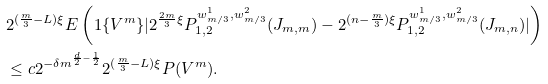Convert formula to latex. <formula><loc_0><loc_0><loc_500><loc_500>& 2 ^ { ( \frac { m } { 3 } - L ) \xi } E \left ( { 1 } \{ V ^ { m } \} | 2 ^ { \frac { 2 m } { 3 } \xi } P ^ { w ^ { 1 } _ { m / 3 } , w ^ { 2 } _ { m / 3 } } _ { 1 , 2 } ( J _ { m , m } ) - 2 ^ { ( n - \frac { m } { 3 } ) \xi } P ^ { w ^ { 1 } _ { m / 3 } , w ^ { 2 } _ { m / 3 } } _ { 1 , 2 } ( J _ { m , n } ) | \right ) \\ & \leq c 2 ^ { - \delta m ^ { \frac { d } { 2 } - \frac { 1 } { 2 } } } 2 ^ { ( \frac { m } { 3 } - L ) \xi } P ( V ^ { m } ) .</formula> 